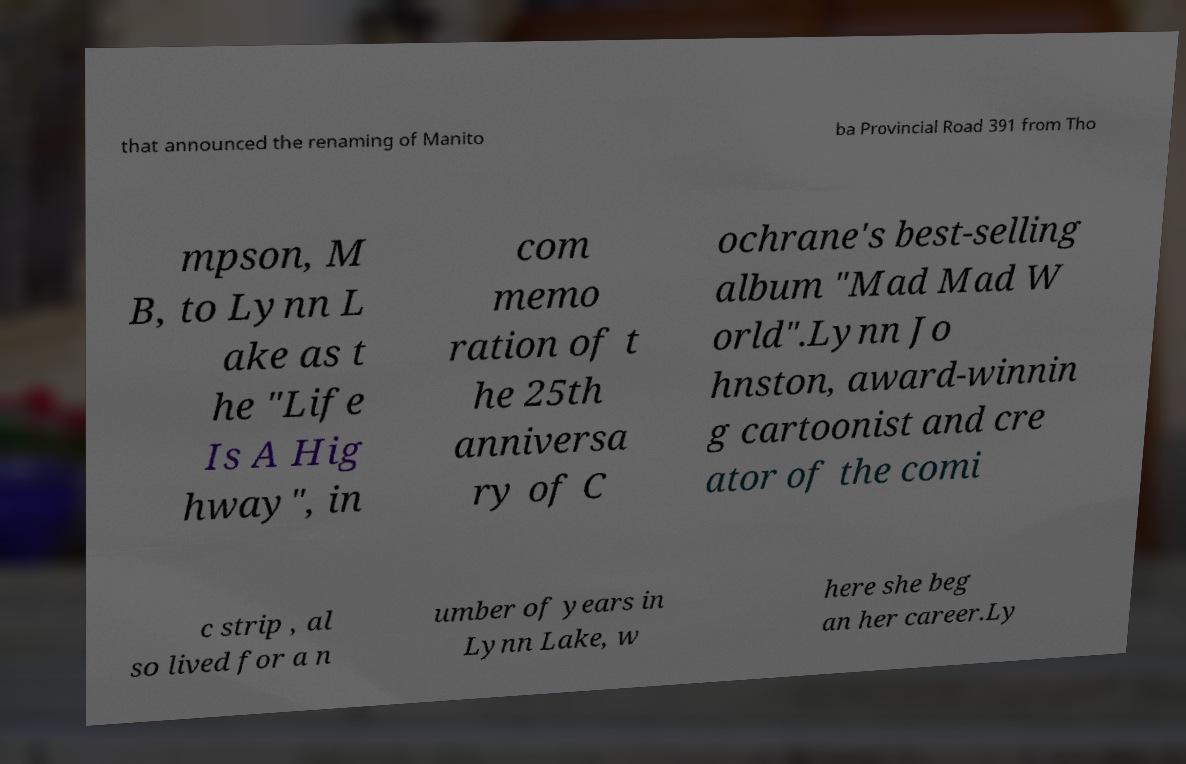For documentation purposes, I need the text within this image transcribed. Could you provide that? that announced the renaming of Manito ba Provincial Road 391 from Tho mpson, M B, to Lynn L ake as t he "Life Is A Hig hway", in com memo ration of t he 25th anniversa ry of C ochrane's best-selling album "Mad Mad W orld".Lynn Jo hnston, award-winnin g cartoonist and cre ator of the comi c strip , al so lived for a n umber of years in Lynn Lake, w here she beg an her career.Ly 